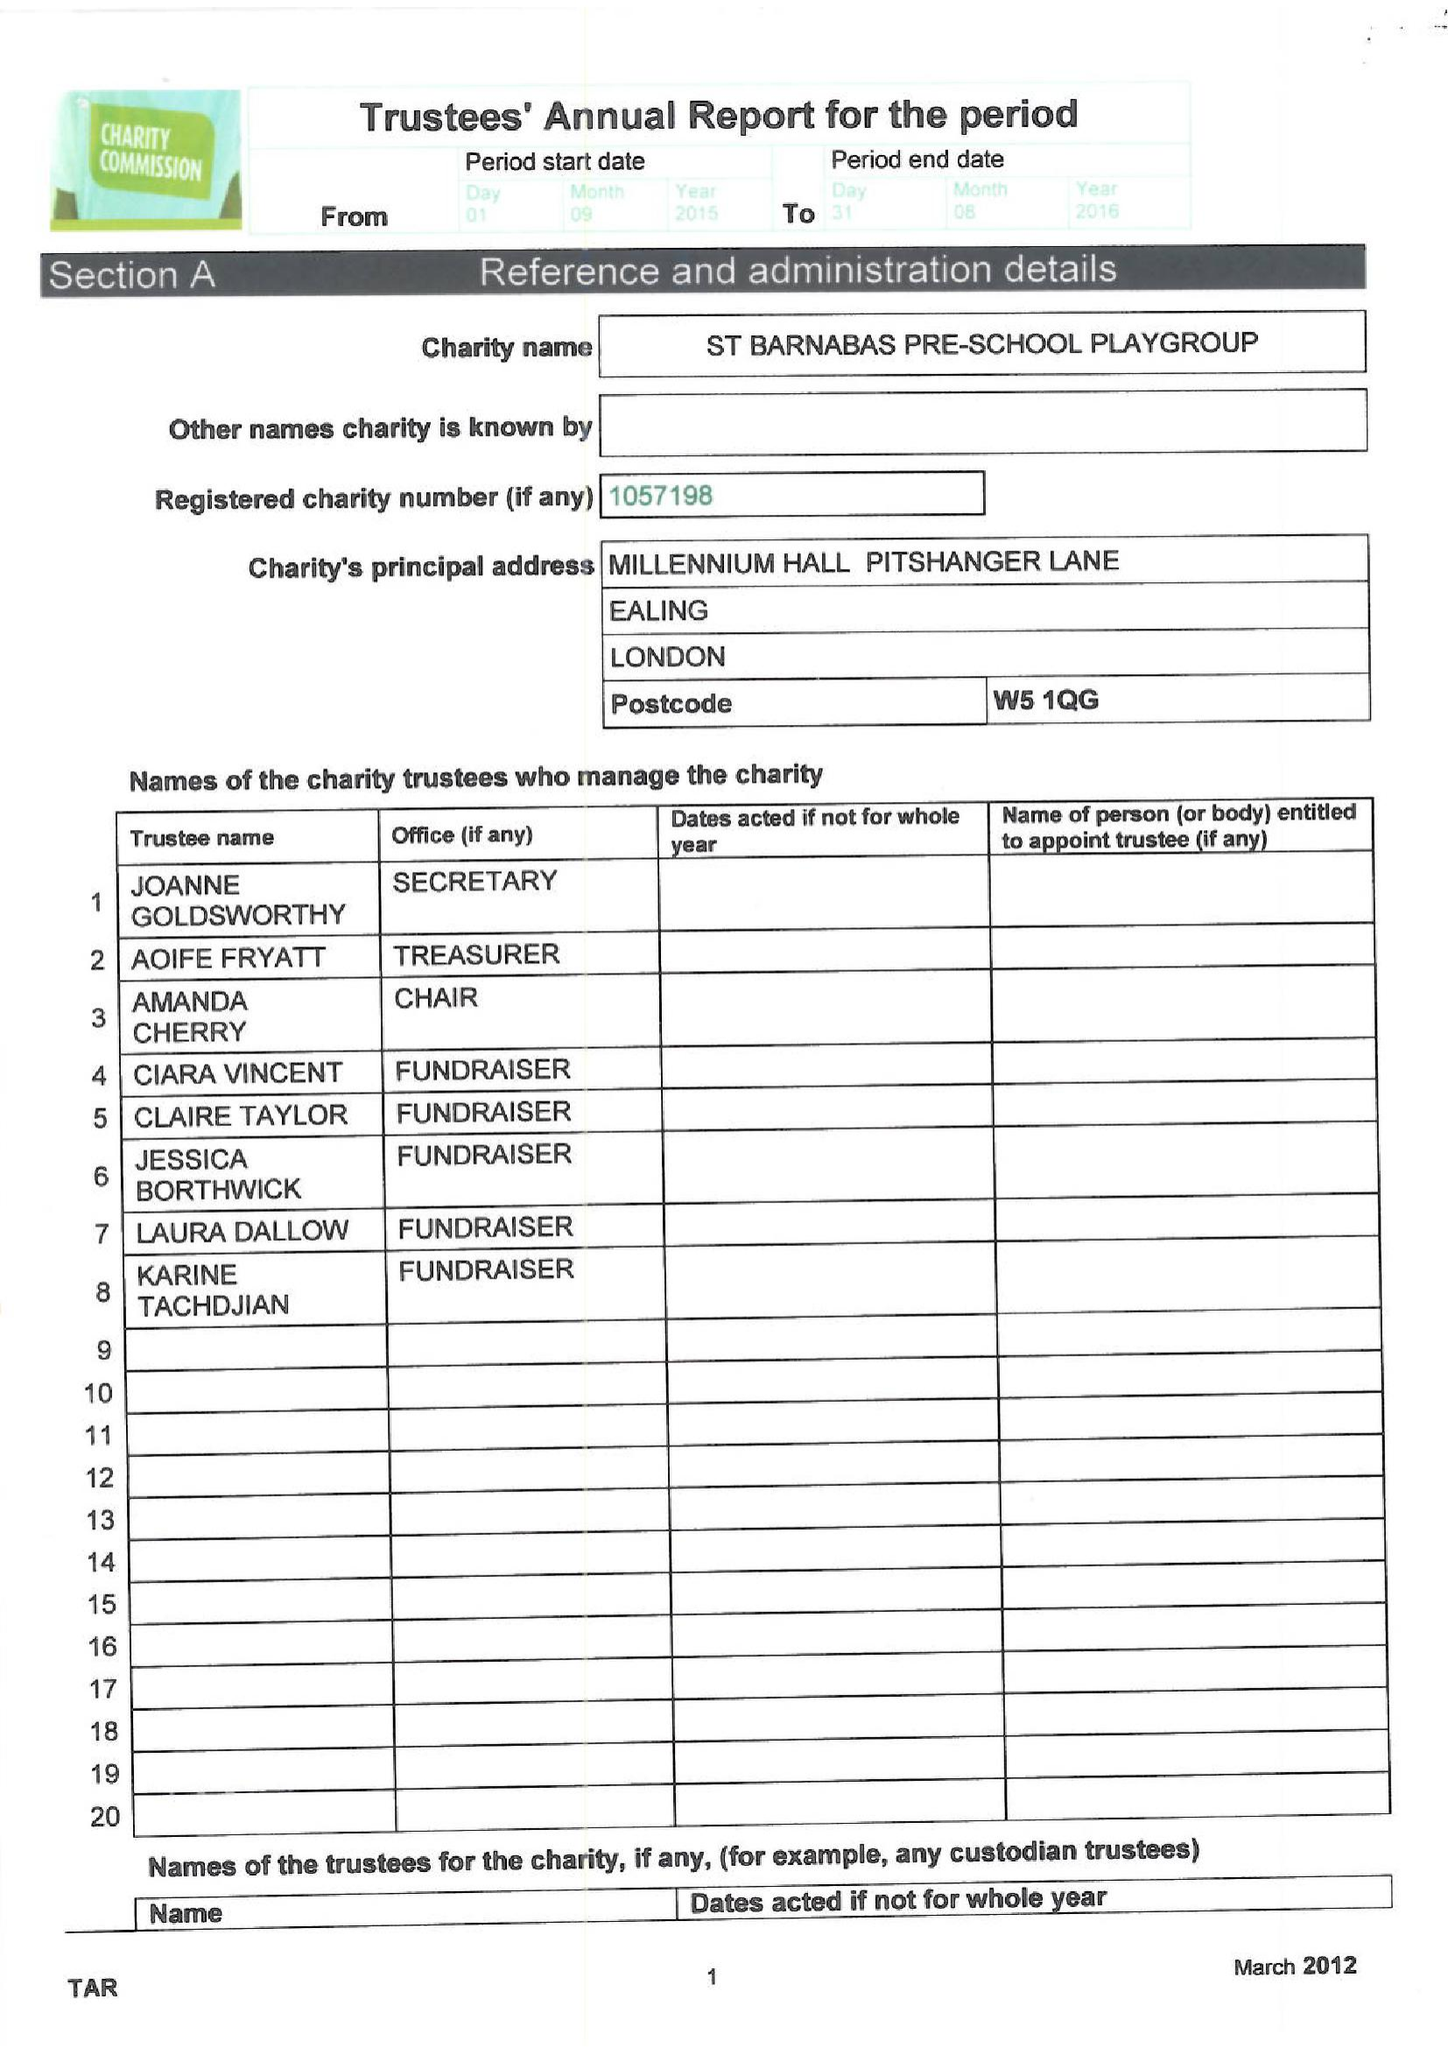What is the value for the charity_name?
Answer the question using a single word or phrase. St Barnabas Pre School Playgroup 